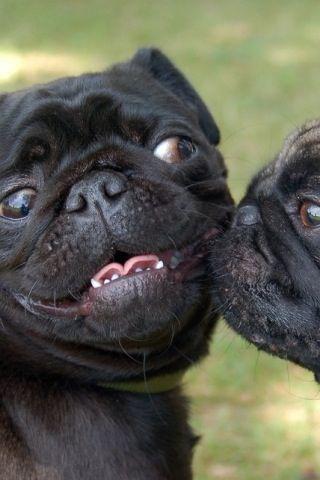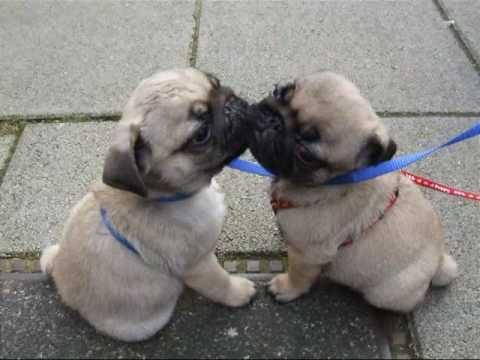The first image is the image on the left, the second image is the image on the right. Given the left and right images, does the statement "The left and right image contains the same number of dogs." hold true? Answer yes or no. Yes. 